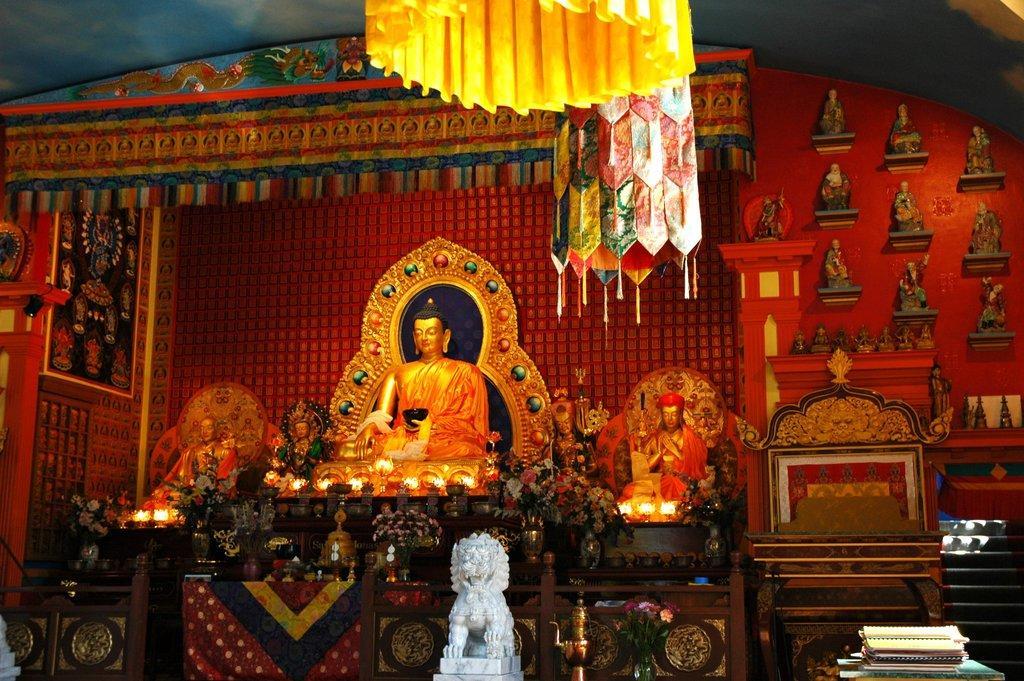Please provide a concise description of this image. In this image I can see a Buddha statue which is orange. I can few statues,lights around and red color background. I can see a colorful cloth. 